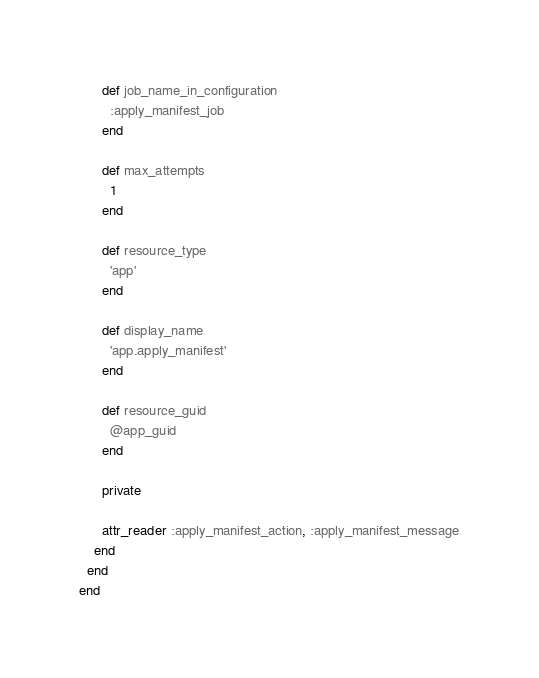<code> <loc_0><loc_0><loc_500><loc_500><_Ruby_>      def job_name_in_configuration
        :apply_manifest_job
      end

      def max_attempts
        1
      end

      def resource_type
        'app'
      end

      def display_name
        'app.apply_manifest'
      end

      def resource_guid
        @app_guid
      end

      private

      attr_reader :apply_manifest_action, :apply_manifest_message
    end
  end
end
</code> 